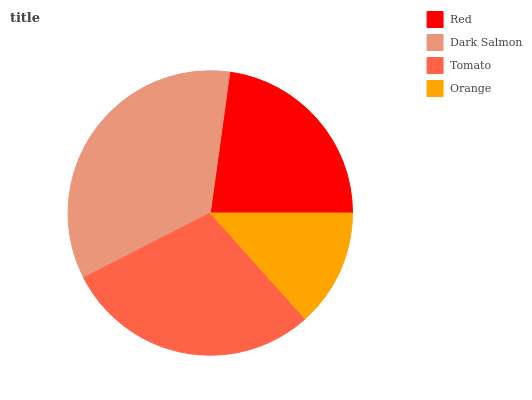Is Orange the minimum?
Answer yes or no. Yes. Is Dark Salmon the maximum?
Answer yes or no. Yes. Is Tomato the minimum?
Answer yes or no. No. Is Tomato the maximum?
Answer yes or no. No. Is Dark Salmon greater than Tomato?
Answer yes or no. Yes. Is Tomato less than Dark Salmon?
Answer yes or no. Yes. Is Tomato greater than Dark Salmon?
Answer yes or no. No. Is Dark Salmon less than Tomato?
Answer yes or no. No. Is Tomato the high median?
Answer yes or no. Yes. Is Red the low median?
Answer yes or no. Yes. Is Orange the high median?
Answer yes or no. No. Is Tomato the low median?
Answer yes or no. No. 